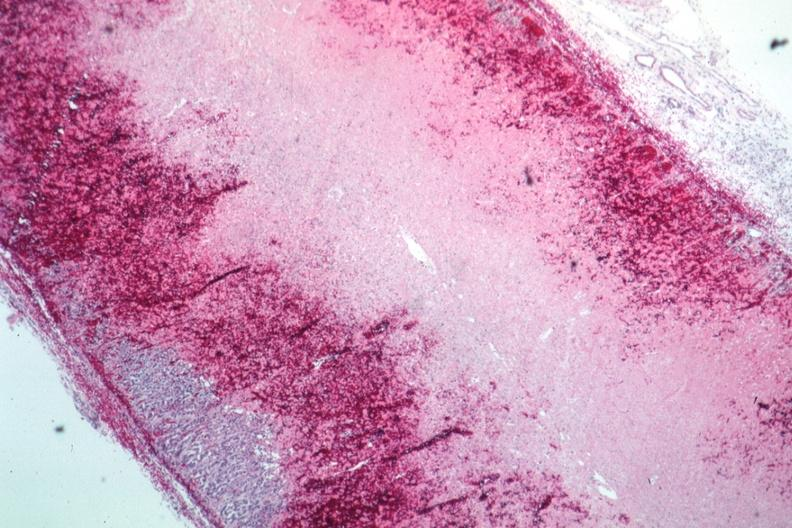s atrophy present?
Answer the question using a single word or phrase. No 